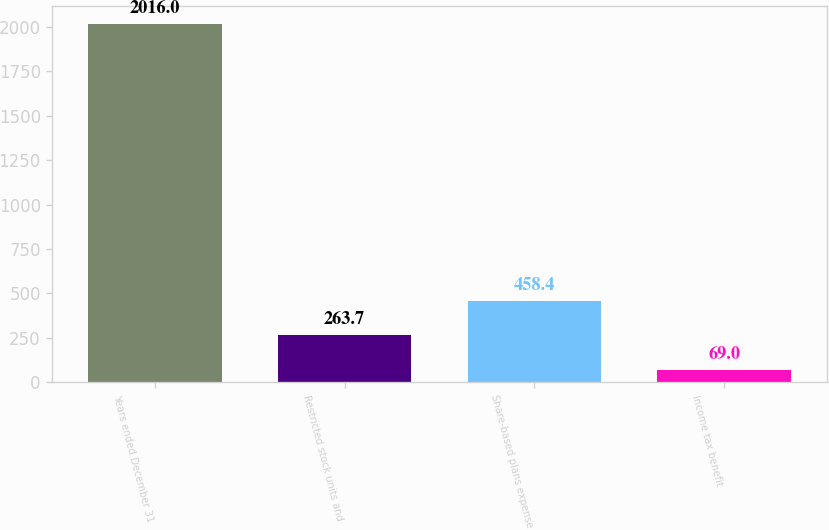<chart> <loc_0><loc_0><loc_500><loc_500><bar_chart><fcel>Years ended December 31<fcel>Restricted stock units and<fcel>Share-based plans expense<fcel>Income tax benefit<nl><fcel>2016<fcel>263.7<fcel>458.4<fcel>69<nl></chart> 